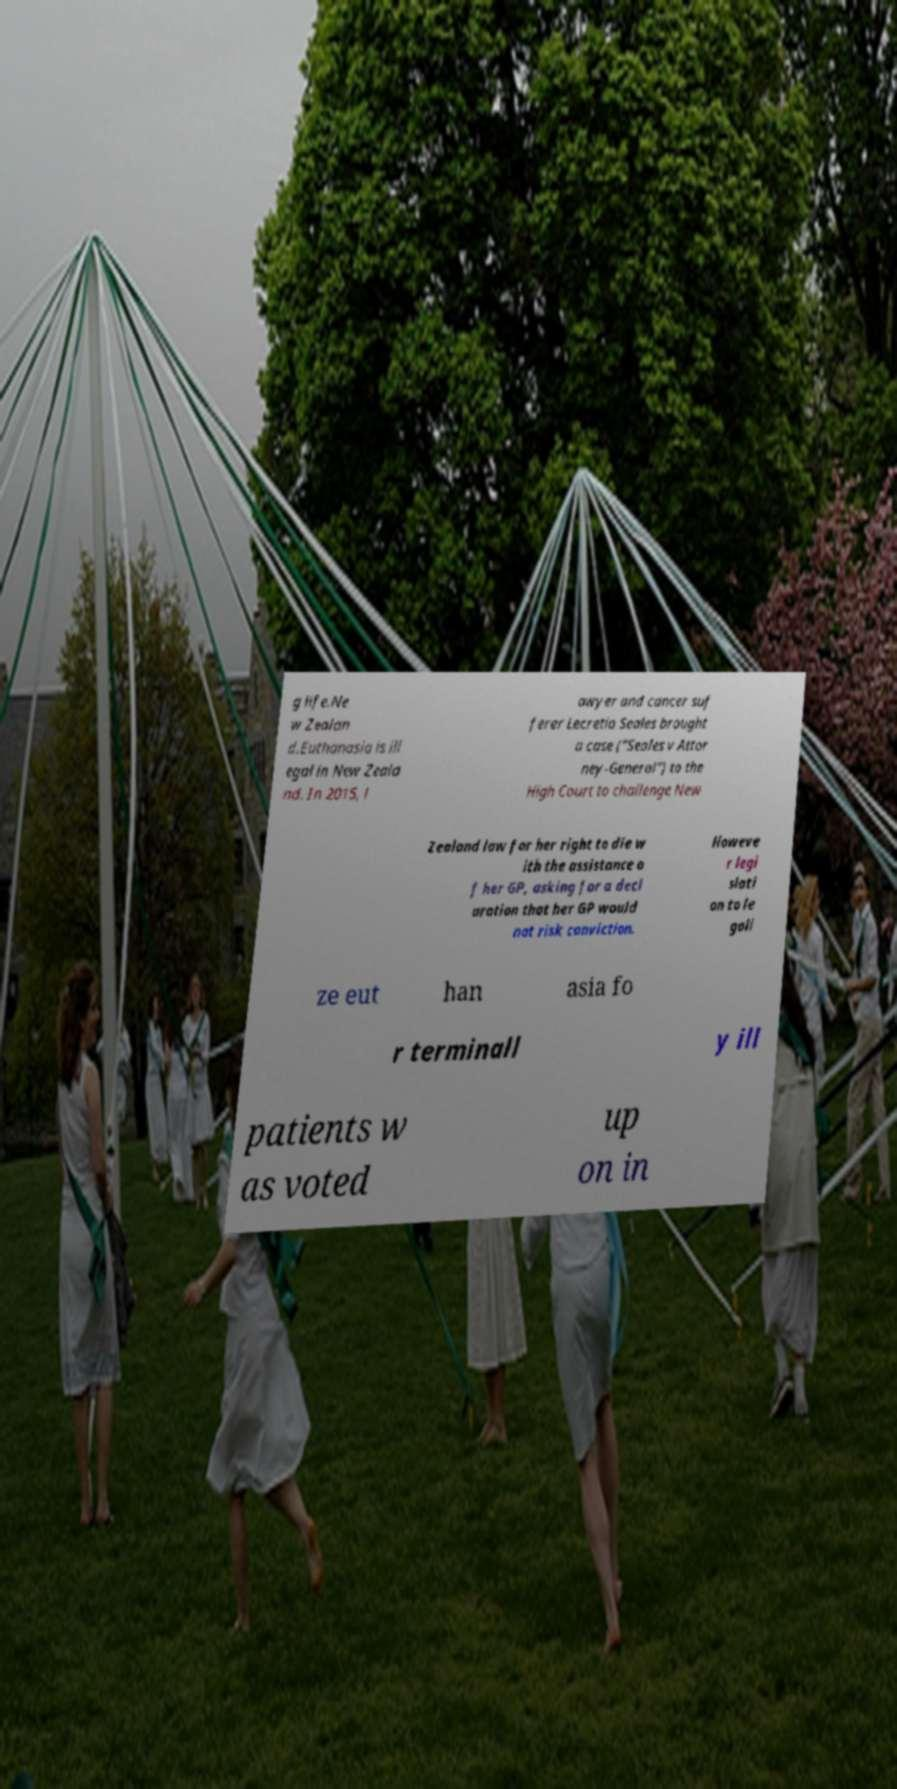Please identify and transcribe the text found in this image. g life.Ne w Zealan d.Euthanasia is ill egal in New Zeala nd. In 2015, l awyer and cancer suf ferer Lecretia Seales brought a case ("Seales v Attor ney-General") to the High Court to challenge New Zealand law for her right to die w ith the assistance o f her GP, asking for a decl aration that her GP would not risk conviction. Howeve r legi slati on to le gali ze eut han asia fo r terminall y ill patients w as voted up on in 